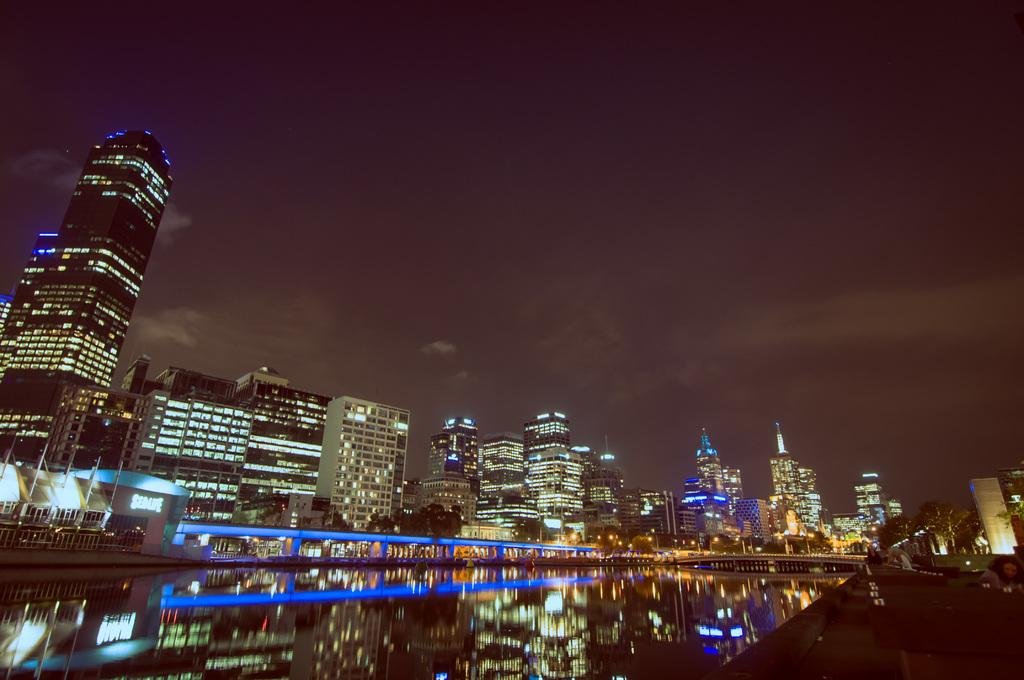What type of location is shown in the image? The image depicts a city. What are some notable features of the city in the image? There are skyscrapers in the image. What natural element can be seen in the image? There is water visible in the image. What type of vegetation is present in the image? Trees are present in the image. What can be seen in the background of the image? The sky is visible in the background of the image. What type of current can be seen flowing through the city in the image? There is no current visible in the image; it is a still representation of a city. How does the air quality appear in the image? The image does not provide information about air quality. 